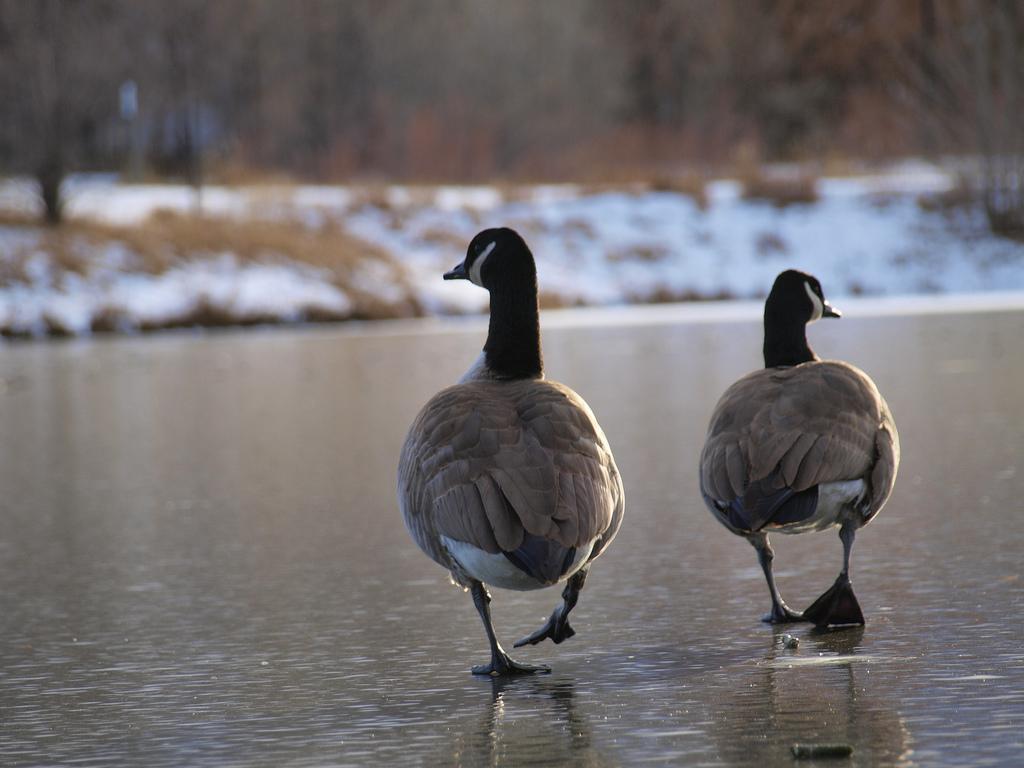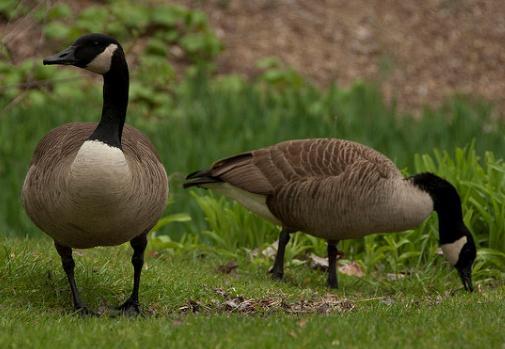The first image is the image on the left, the second image is the image on the right. Considering the images on both sides, is "Two black-necked geese with backs to the camera are standing in water." valid? Answer yes or no. Yes. The first image is the image on the left, the second image is the image on the right. For the images shown, is this caption "There are two birds in the right image both facing towards the left." true? Answer yes or no. No. 